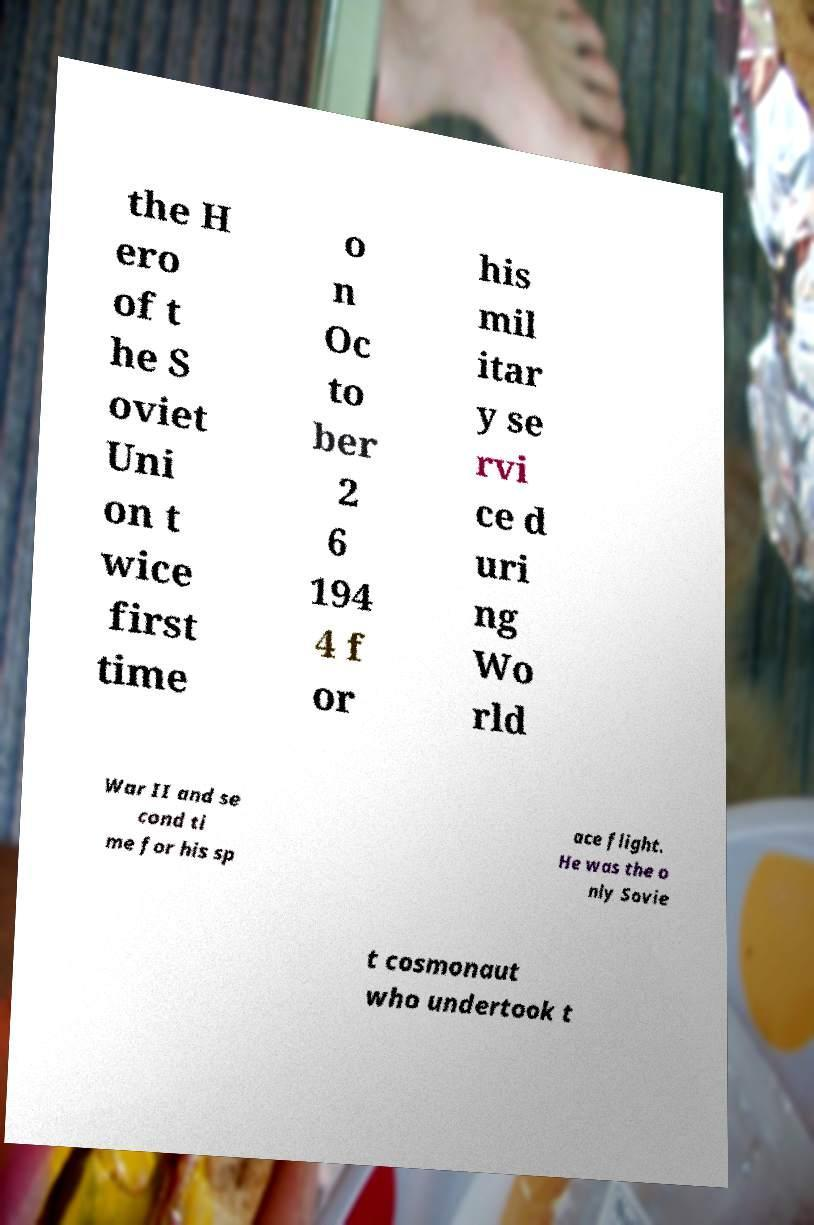Could you extract and type out the text from this image? the H ero of t he S oviet Uni on t wice first time o n Oc to ber 2 6 194 4 f or his mil itar y se rvi ce d uri ng Wo rld War II and se cond ti me for his sp ace flight. He was the o nly Sovie t cosmonaut who undertook t 